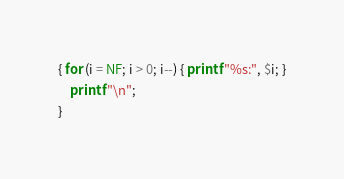Convert code to text. <code><loc_0><loc_0><loc_500><loc_500><_Awk_>{ for (i = NF; i > 0; i--) { printf "%s:", $i; }
	printf "\n";
}
</code> 